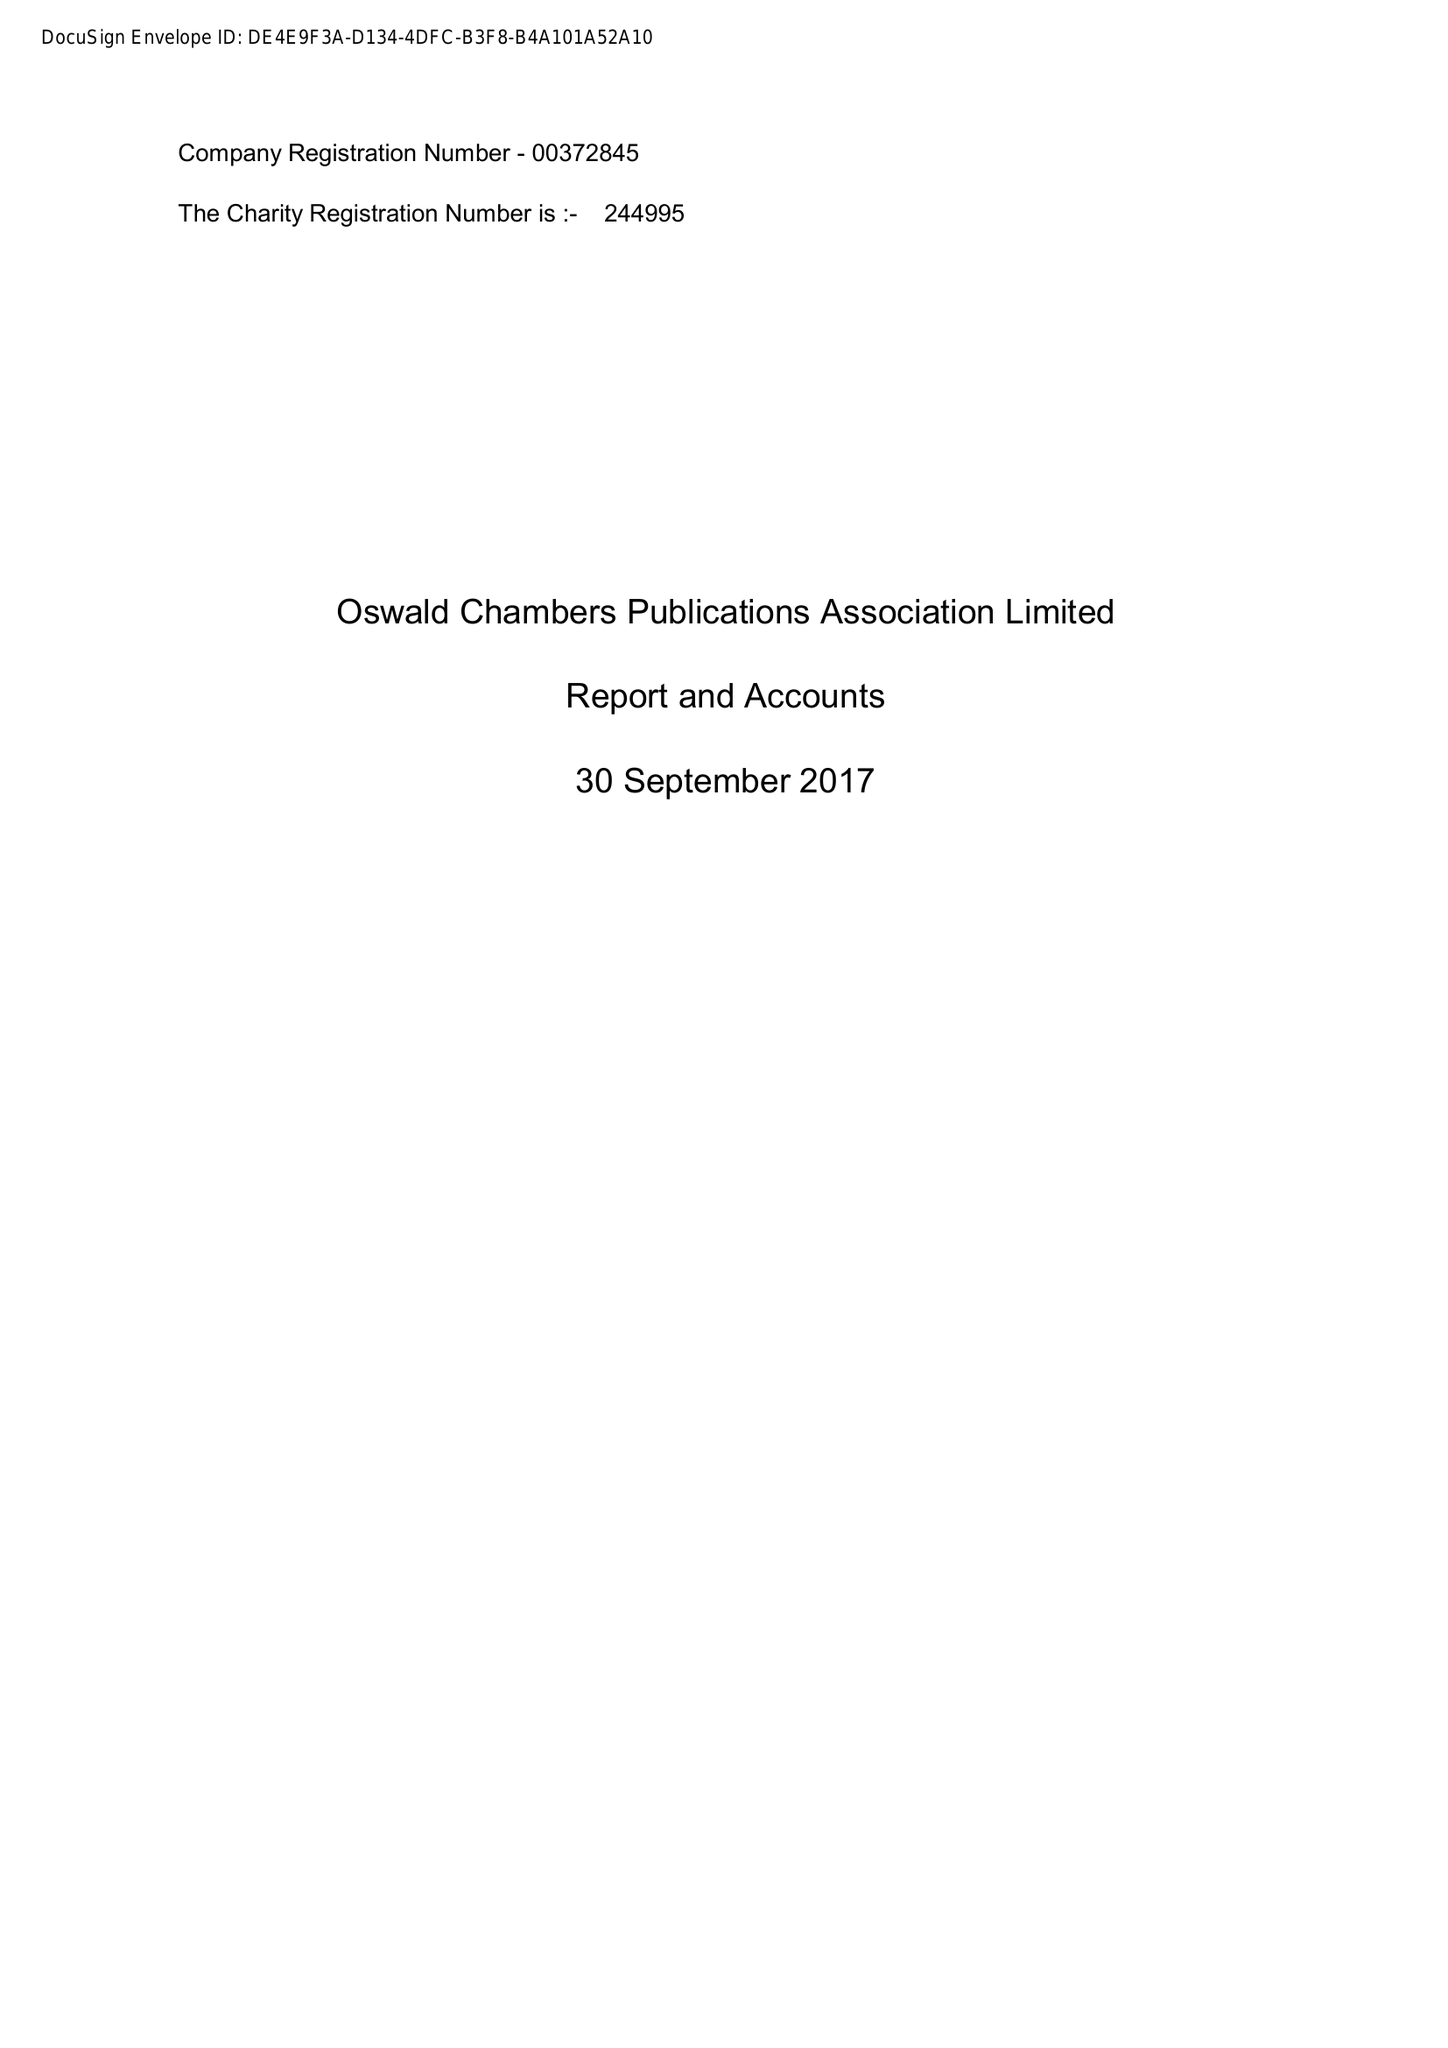What is the value for the charity_name?
Answer the question using a single word or phrase. Oswald Chambers Publications Association Ltd. 